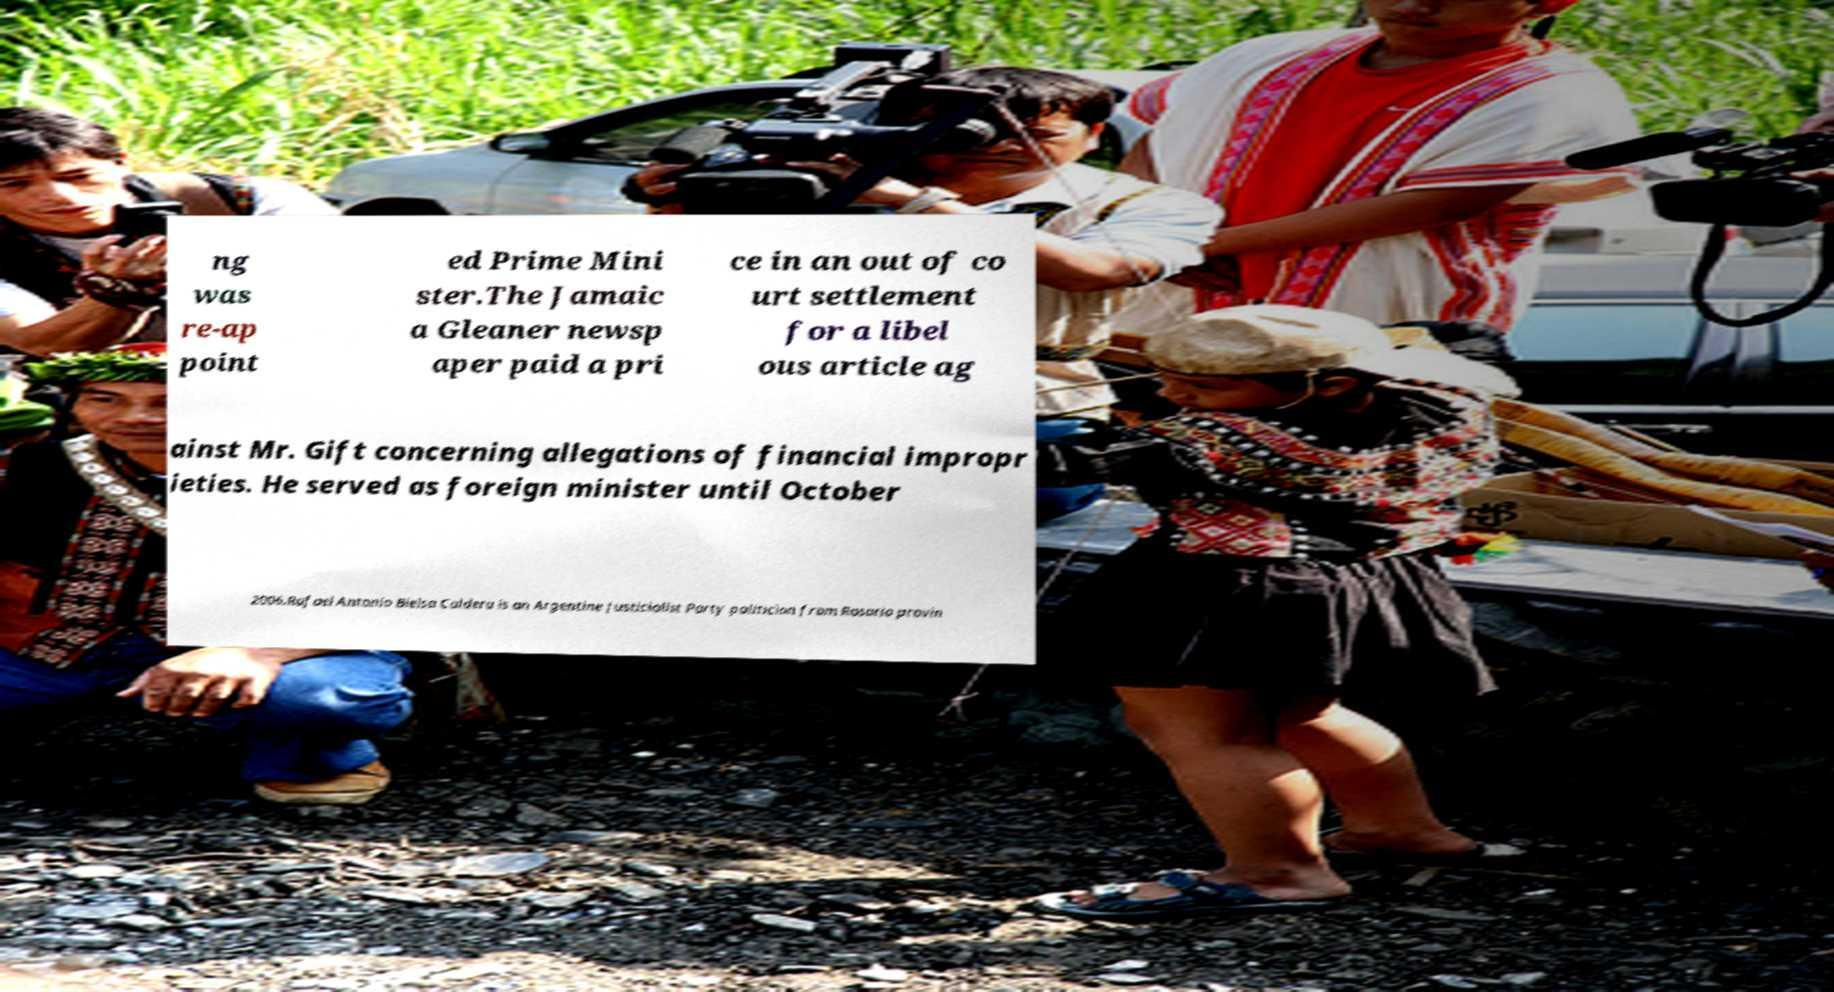For documentation purposes, I need the text within this image transcribed. Could you provide that? ng was re-ap point ed Prime Mini ster.The Jamaic a Gleaner newsp aper paid a pri ce in an out of co urt settlement for a libel ous article ag ainst Mr. Gift concerning allegations of financial impropr ieties. He served as foreign minister until October 2006.Rafael Antonio Bielsa Caldera is an Argentine Justicialist Party politician from Rosario provin 